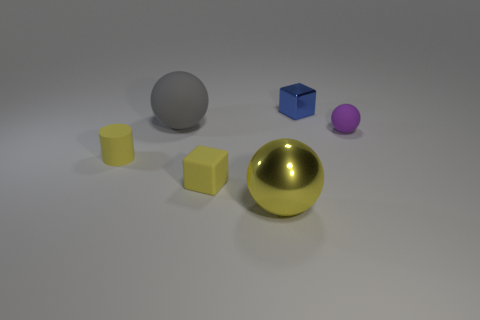How many other objects are the same material as the blue object?
Your response must be concise. 1. There is a tiny matte object that is right of the large gray matte thing and to the left of the blue shiny thing; what shape is it?
Provide a succinct answer. Cube. There is a sphere in front of the small matte cylinder; does it have the same size as the rubber cylinder left of the big gray object?
Your response must be concise. No. What shape is the small purple thing that is made of the same material as the gray thing?
Give a very brief answer. Sphere. Are there any other things that are the same shape as the large yellow object?
Your answer should be very brief. Yes. There is a big sphere in front of the small thing to the left of the large object that is behind the purple sphere; what is its color?
Keep it short and to the point. Yellow. Is the number of big yellow metal spheres behind the tiny ball less than the number of big yellow objects to the right of the tiny metal cube?
Your answer should be compact. No. Is the small blue metallic object the same shape as the large yellow shiny object?
Provide a succinct answer. No. What number of purple shiny blocks are the same size as the purple object?
Your answer should be very brief. 0. Is the number of big gray objects that are behind the big matte object less than the number of tiny purple rubber balls?
Provide a succinct answer. Yes. 